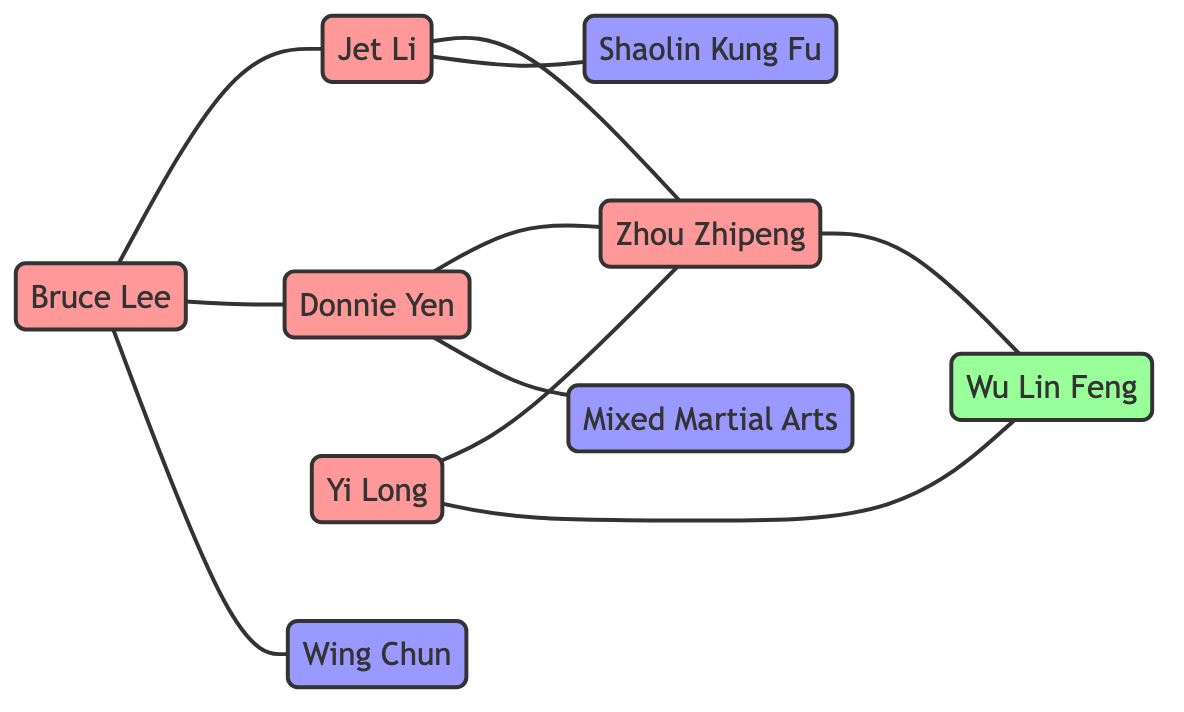What is the total number of nodes in the diagram? To find the total number of nodes, we count each distinct node listed. There are 5 martial artists, 1 promotion, and 3 martial art styles, totaling 9 nodes.
Answer: 9 Who is connected to Zhou Zhipeng in the graph? Zhou Zhipeng is connected to Jet Li, Donnie Yen, and Yi Long through inspiration and influence relationships shown in the edges.
Answer: Jet Li, Donnie Yen, Yi Long What type of relationship exists between Bruce Lee and Donnie Yen? The edge connecting Bruce Lee and Donnie Yen is labeled "Inspiration," indicating that Bruce Lee serves as an inspiring figure for Donnie Yen.
Answer: Inspiration How many practitioners are there in total? There are 3 practitioners in total: Bruce Lee (Wing Chun), Jet Li (Shaolin Kung Fu), and Donnie Yen (Mixed Martial Arts).
Answer: 3 Which martial art style is connected to Jet Li? The edge from Jet Li to Shaolin Kung Fu depicts that he practices this martial art style, so the specific art style connected is Shaolin Kung Fu.
Answer: Shaolin Kung Fu How many direct competitors does Yi Long have in Wu Lin Feng? The edge indicates that Yi Long is a competitor in Wu Lin Feng, and he directly connects to this promotion, meaning he has one direct competitor, which is Zhou Zhipeng.
Answer: 1 Who has inspired Zhou Zhipeng? The nodes connected to Zhou Zhipeng through inspiration are Jet Li and Donnie Yen, showing they have inspired Zhou Zhipeng.
Answer: Jet Li, Donnie Yen What martial art style does Bruce Lee practice? The edge connecting Bruce Lee and Wing Chun indicates that Bruce Lee practices Wing Chun as his martial art style.
Answer: Wing Chun Which martial artist influences Zhou Zhipeng? The diagram shows that Yi Long also influences Zhou Zhipeng, highlighting that Yi Long has a direct influence relationship with him.
Answer: Yi Long 